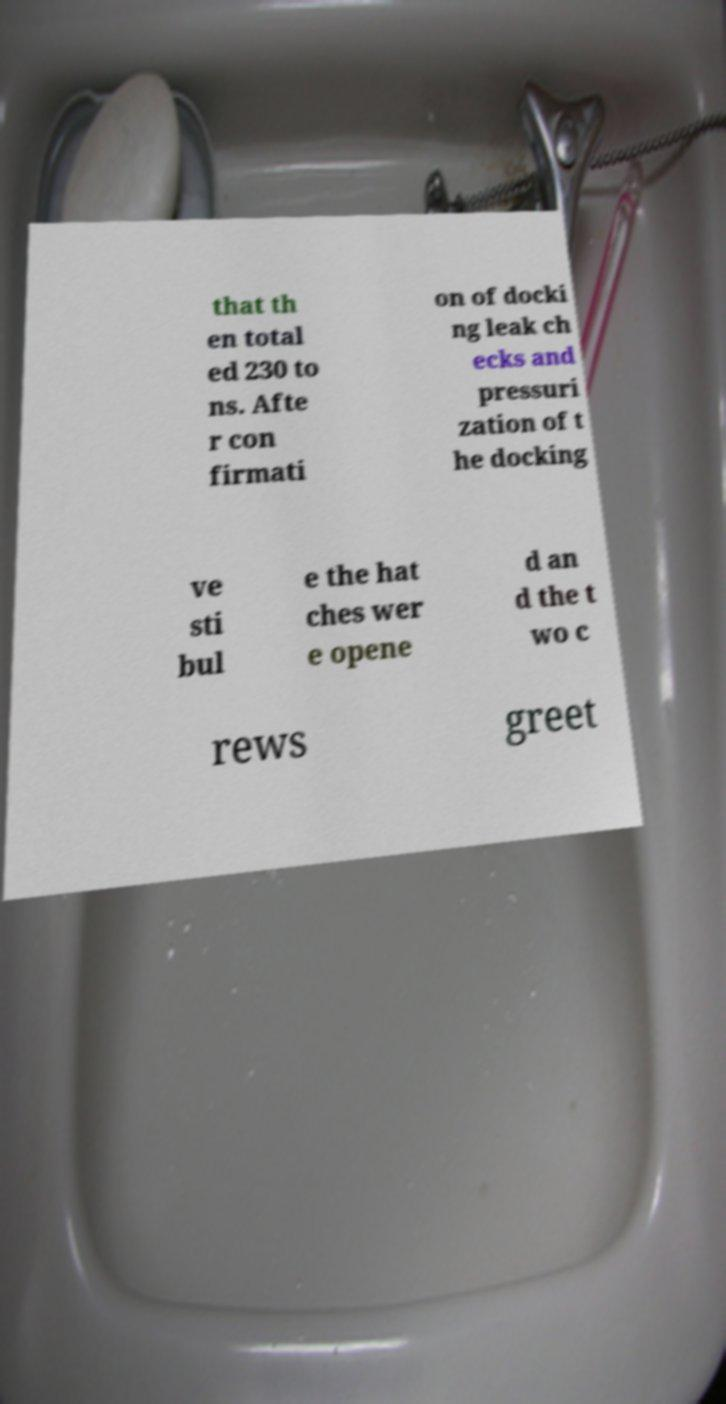Please identify and transcribe the text found in this image. that th en total ed 230 to ns. Afte r con firmati on of docki ng leak ch ecks and pressuri zation of t he docking ve sti bul e the hat ches wer e opene d an d the t wo c rews greet 